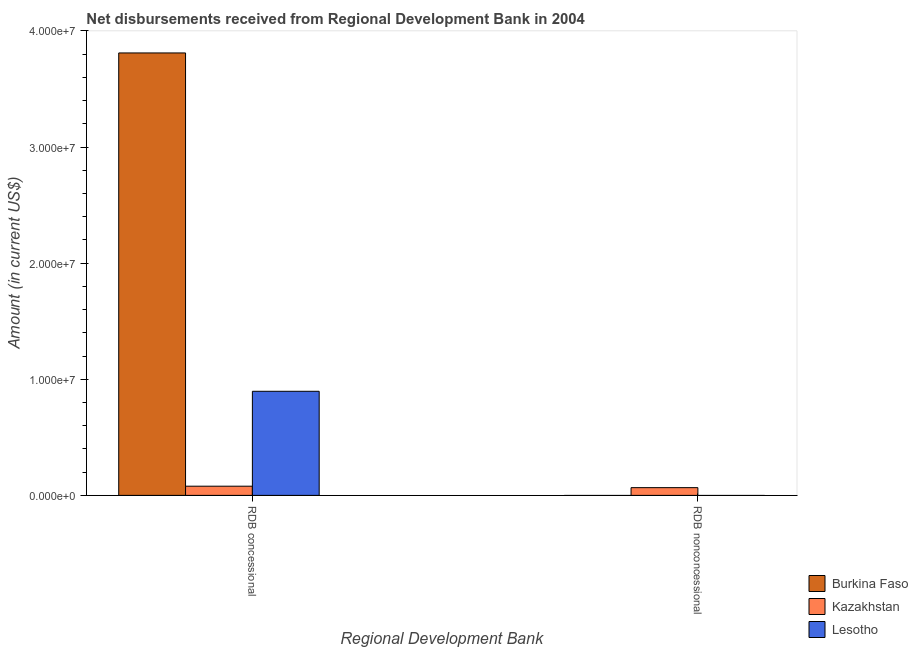How many different coloured bars are there?
Give a very brief answer. 3. How many bars are there on the 2nd tick from the left?
Your answer should be compact. 1. How many bars are there on the 2nd tick from the right?
Provide a succinct answer. 3. What is the label of the 1st group of bars from the left?
Ensure brevity in your answer.  RDB concessional. What is the net non concessional disbursements from rdb in Kazakhstan?
Give a very brief answer. 6.67e+05. Across all countries, what is the maximum net non concessional disbursements from rdb?
Provide a succinct answer. 6.67e+05. Across all countries, what is the minimum net concessional disbursements from rdb?
Offer a very short reply. 7.91e+05. In which country was the net non concessional disbursements from rdb maximum?
Your answer should be compact. Kazakhstan. What is the total net non concessional disbursements from rdb in the graph?
Offer a terse response. 6.67e+05. What is the difference between the net concessional disbursements from rdb in Kazakhstan and that in Burkina Faso?
Offer a very short reply. -3.73e+07. What is the difference between the net non concessional disbursements from rdb in Burkina Faso and the net concessional disbursements from rdb in Kazakhstan?
Provide a succinct answer. -7.91e+05. What is the average net non concessional disbursements from rdb per country?
Your answer should be compact. 2.22e+05. What is the difference between the net concessional disbursements from rdb and net non concessional disbursements from rdb in Kazakhstan?
Your answer should be compact. 1.24e+05. In how many countries, is the net non concessional disbursements from rdb greater than 30000000 US$?
Your response must be concise. 0. What is the ratio of the net concessional disbursements from rdb in Kazakhstan to that in Burkina Faso?
Your response must be concise. 0.02. In how many countries, is the net concessional disbursements from rdb greater than the average net concessional disbursements from rdb taken over all countries?
Keep it short and to the point. 1. How many bars are there?
Provide a short and direct response. 4. Are the values on the major ticks of Y-axis written in scientific E-notation?
Your response must be concise. Yes. Does the graph contain any zero values?
Make the answer very short. Yes. Does the graph contain grids?
Your response must be concise. No. Where does the legend appear in the graph?
Your answer should be very brief. Bottom right. How many legend labels are there?
Offer a very short reply. 3. What is the title of the graph?
Keep it short and to the point. Net disbursements received from Regional Development Bank in 2004. What is the label or title of the X-axis?
Provide a succinct answer. Regional Development Bank. What is the label or title of the Y-axis?
Provide a succinct answer. Amount (in current US$). What is the Amount (in current US$) in Burkina Faso in RDB concessional?
Your answer should be compact. 3.81e+07. What is the Amount (in current US$) in Kazakhstan in RDB concessional?
Provide a short and direct response. 7.91e+05. What is the Amount (in current US$) in Lesotho in RDB concessional?
Offer a very short reply. 8.96e+06. What is the Amount (in current US$) of Burkina Faso in RDB nonconcessional?
Ensure brevity in your answer.  0. What is the Amount (in current US$) in Kazakhstan in RDB nonconcessional?
Your answer should be very brief. 6.67e+05. Across all Regional Development Bank, what is the maximum Amount (in current US$) in Burkina Faso?
Your response must be concise. 3.81e+07. Across all Regional Development Bank, what is the maximum Amount (in current US$) of Kazakhstan?
Offer a very short reply. 7.91e+05. Across all Regional Development Bank, what is the maximum Amount (in current US$) of Lesotho?
Make the answer very short. 8.96e+06. Across all Regional Development Bank, what is the minimum Amount (in current US$) in Burkina Faso?
Ensure brevity in your answer.  0. Across all Regional Development Bank, what is the minimum Amount (in current US$) in Kazakhstan?
Make the answer very short. 6.67e+05. What is the total Amount (in current US$) in Burkina Faso in the graph?
Offer a very short reply. 3.81e+07. What is the total Amount (in current US$) in Kazakhstan in the graph?
Ensure brevity in your answer.  1.46e+06. What is the total Amount (in current US$) of Lesotho in the graph?
Offer a terse response. 8.96e+06. What is the difference between the Amount (in current US$) in Kazakhstan in RDB concessional and that in RDB nonconcessional?
Your answer should be compact. 1.24e+05. What is the difference between the Amount (in current US$) of Burkina Faso in RDB concessional and the Amount (in current US$) of Kazakhstan in RDB nonconcessional?
Offer a terse response. 3.74e+07. What is the average Amount (in current US$) in Burkina Faso per Regional Development Bank?
Keep it short and to the point. 1.91e+07. What is the average Amount (in current US$) in Kazakhstan per Regional Development Bank?
Make the answer very short. 7.29e+05. What is the average Amount (in current US$) in Lesotho per Regional Development Bank?
Ensure brevity in your answer.  4.48e+06. What is the difference between the Amount (in current US$) of Burkina Faso and Amount (in current US$) of Kazakhstan in RDB concessional?
Provide a succinct answer. 3.73e+07. What is the difference between the Amount (in current US$) in Burkina Faso and Amount (in current US$) in Lesotho in RDB concessional?
Your answer should be very brief. 2.91e+07. What is the difference between the Amount (in current US$) in Kazakhstan and Amount (in current US$) in Lesotho in RDB concessional?
Offer a very short reply. -8.17e+06. What is the ratio of the Amount (in current US$) of Kazakhstan in RDB concessional to that in RDB nonconcessional?
Ensure brevity in your answer.  1.19. What is the difference between the highest and the second highest Amount (in current US$) of Kazakhstan?
Make the answer very short. 1.24e+05. What is the difference between the highest and the lowest Amount (in current US$) of Burkina Faso?
Your answer should be very brief. 3.81e+07. What is the difference between the highest and the lowest Amount (in current US$) of Kazakhstan?
Make the answer very short. 1.24e+05. What is the difference between the highest and the lowest Amount (in current US$) in Lesotho?
Provide a short and direct response. 8.96e+06. 